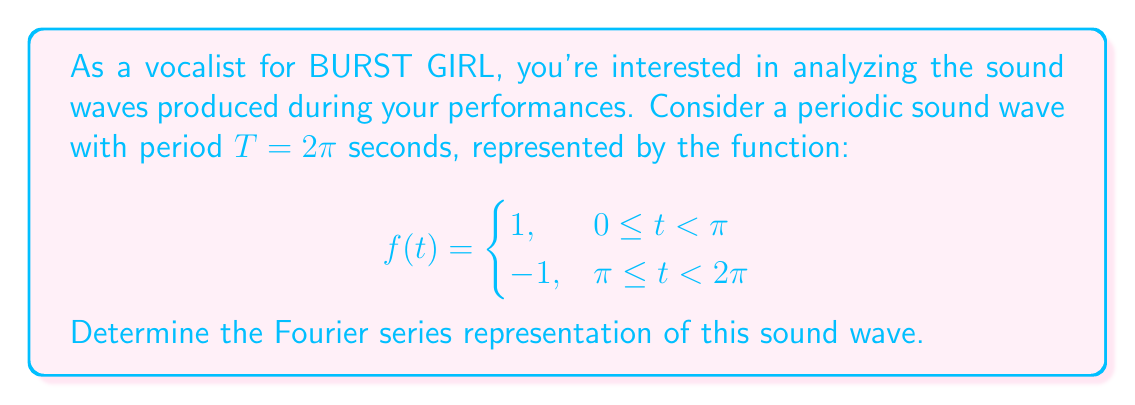Give your solution to this math problem. To find the Fourier series of the given periodic function, we need to calculate the Fourier coefficients $a_0$, $a_n$, and $b_n$. The Fourier series is represented as:

$$f(t) = \frac{a_0}{2} + \sum_{n=1}^{\infty} (a_n \cos(n\omega t) + b_n \sin(n\omega t))$$

where $\omega = \frac{2\pi}{T} = 1$ (since $T = 2\pi$).

Step 1: Calculate $a_0$
$$a_0 = \frac{1}{\pi} \int_0^{2\pi} f(t) dt = \frac{1}{\pi} \left(\int_0^{\pi} 1 dt + \int_{\pi}^{2\pi} (-1) dt\right) = \frac{1}{\pi} (\pi - \pi) = 0$$

Step 2: Calculate $a_n$
$$\begin{align*}
a_n &= \frac{1}{\pi} \int_0^{2\pi} f(t) \cos(nt) dt \\
&= \frac{1}{\pi} \left(\int_0^{\pi} \cos(nt) dt - \int_{\pi}^{2\pi} \cos(nt) dt\right) \\
&= \frac{1}{\pi} \left[\frac{\sin(nt)}{n}\right]_0^{\pi} - \frac{1}{\pi} \left[\frac{\sin(nt)}{n}\right]_{\pi}^{2\pi} \\
&= \frac{1}{\pi n} (\sin(n\pi) - \sin(0) - \sin(2n\pi) + \sin(n\pi)) \\
&= 0
\end{align*}$$

Step 3: Calculate $b_n$
$$\begin{align*}
b_n &= \frac{1}{\pi} \int_0^{2\pi} f(t) \sin(nt) dt \\
&= \frac{1}{\pi} \left(\int_0^{\pi} \sin(nt) dt - \int_{\pi}^{2\pi} \sin(nt) dt\right) \\
&= \frac{1}{\pi} \left[-\frac{\cos(nt)}{n}\right]_0^{\pi} + \frac{1}{\pi} \left[\frac{\cos(nt)}{n}\right]_{\pi}^{2\pi} \\
&= \frac{1}{\pi n} (-\cos(n\pi) + \cos(0) + \cos(2n\pi) - \cos(n\pi)) \\
&= \frac{2}{\pi n} (1 - \cos(n\pi)) \\
&= \begin{cases}
0, & \text{if } n \text{ is even} \\
\frac{4}{\pi n}, & \text{if } n \text{ is odd}
\end{cases}
\end{align*}$$

Step 4: Construct the Fourier series
Since $a_0 = 0$ and $a_n = 0$ for all $n$, the Fourier series consists only of sine terms with odd coefficients:

$$f(t) = \frac{4}{\pi} \sum_{k=0}^{\infty} \frac{\sin((2k+1)t)}{2k+1}$$
Answer: The Fourier series representation of the given sound wave is:

$$f(t) = \frac{4}{\pi} \sum_{k=0}^{\infty} \frac{\sin((2k+1)t)}{2k+1}$$ 